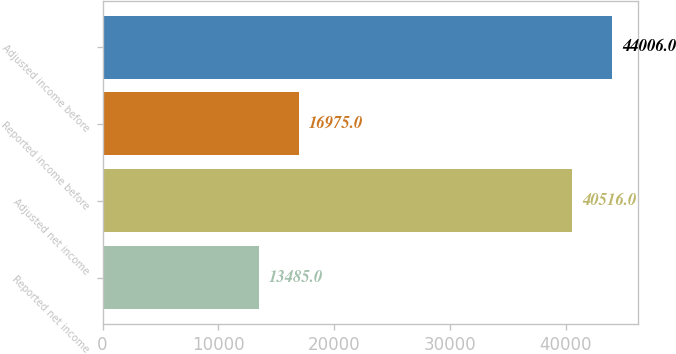<chart> <loc_0><loc_0><loc_500><loc_500><bar_chart><fcel>Reported net income<fcel>Adjusted net income<fcel>Reported income before<fcel>Adjusted income before<nl><fcel>13485<fcel>40516<fcel>16975<fcel>44006<nl></chart> 